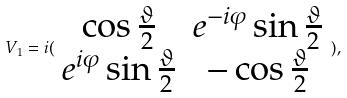Convert formula to latex. <formula><loc_0><loc_0><loc_500><loc_500>V _ { 1 } = i ( \begin{array} { c c } \cos \frac { \vartheta } { 2 } & e ^ { - i \varphi } \sin \frac { \vartheta } { 2 } \\ e ^ { i \varphi } \sin \frac { \vartheta } { 2 } & - \cos \frac { \vartheta } { 2 } \end{array} ) ,</formula> 